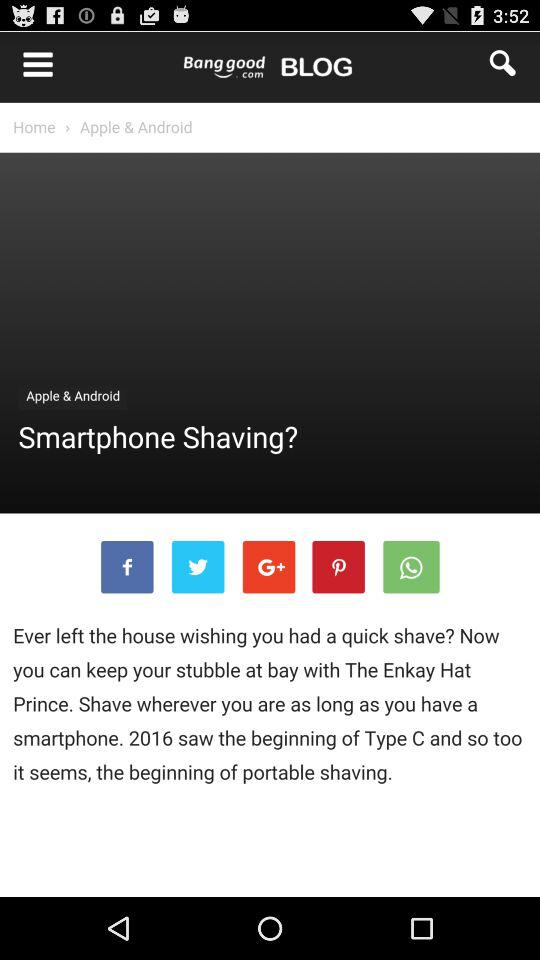What are the names of the categories? The names of the categories are "Home and Garden", "Pet Supplies", "Cat", "Dog", "Home Textiles", "Home Decor", "Wall Art", "Carpets, Mats & Rugs", "Lights & Lighting", "Others", "LED Lighting", "Pillows & Cushions", "LED Night Lights", "Hamster", "Decorative Crafts", "Housekeeping", "Home Cleaning Supplies", "Gardening", "Kitchen,Dining & Bar", "Items Storage & Organization", "Electronic Accessories & Gadgets" and "Tattoo Machines". 